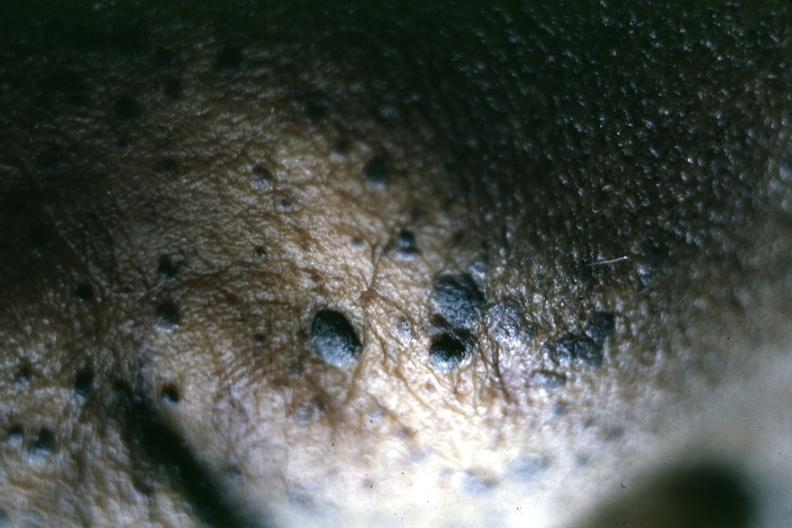s another fiber other frame present?
Answer the question using a single word or phrase. No 